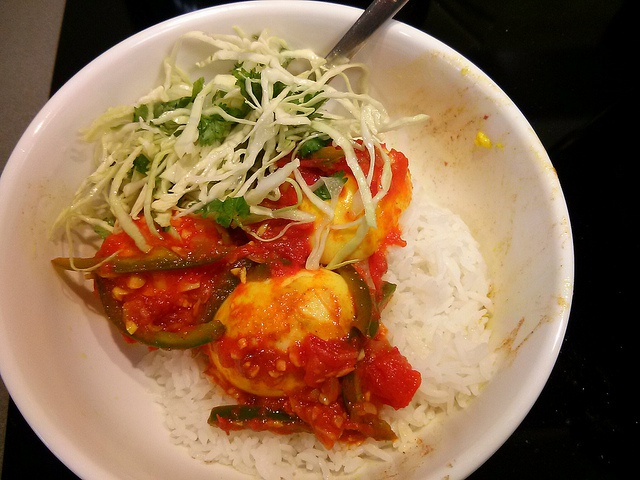Describe the objects in this image and their specific colors. I can see bowl in black and tan tones, dining table in black, darkgray, and gray tones, and spoon in black, gray, and tan tones in this image. 